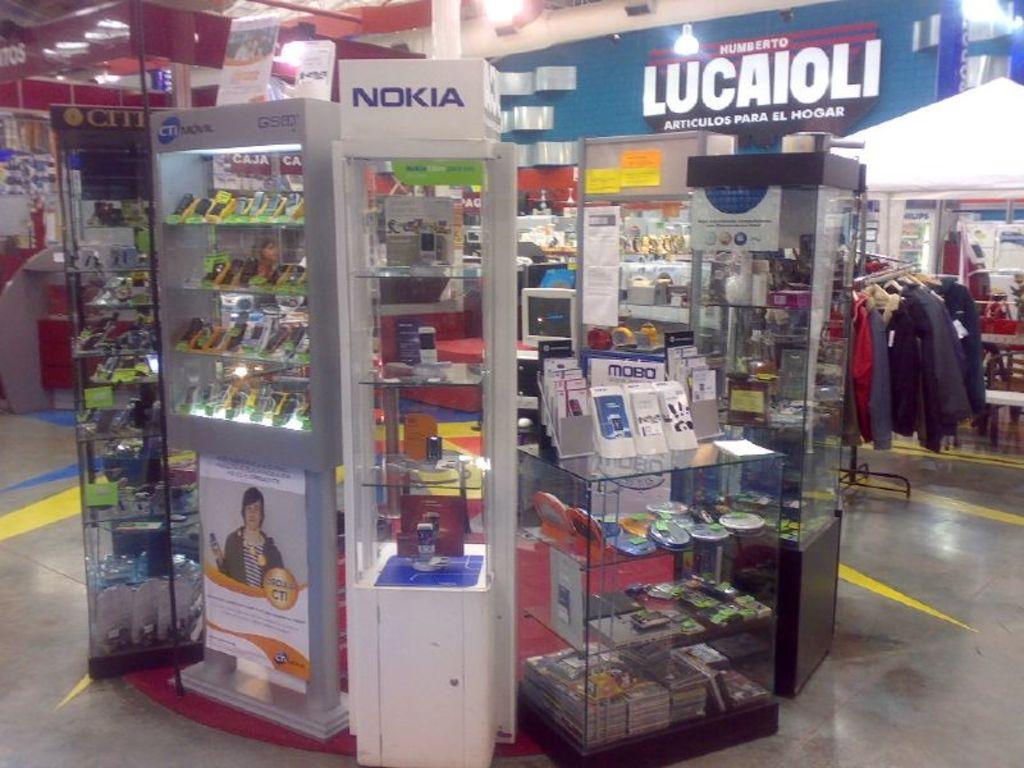What is the name of the store logo on the blue brick?
Offer a very short reply. Lucaioli. What is the name written on the white display case?
Ensure brevity in your answer.  Nokia. 